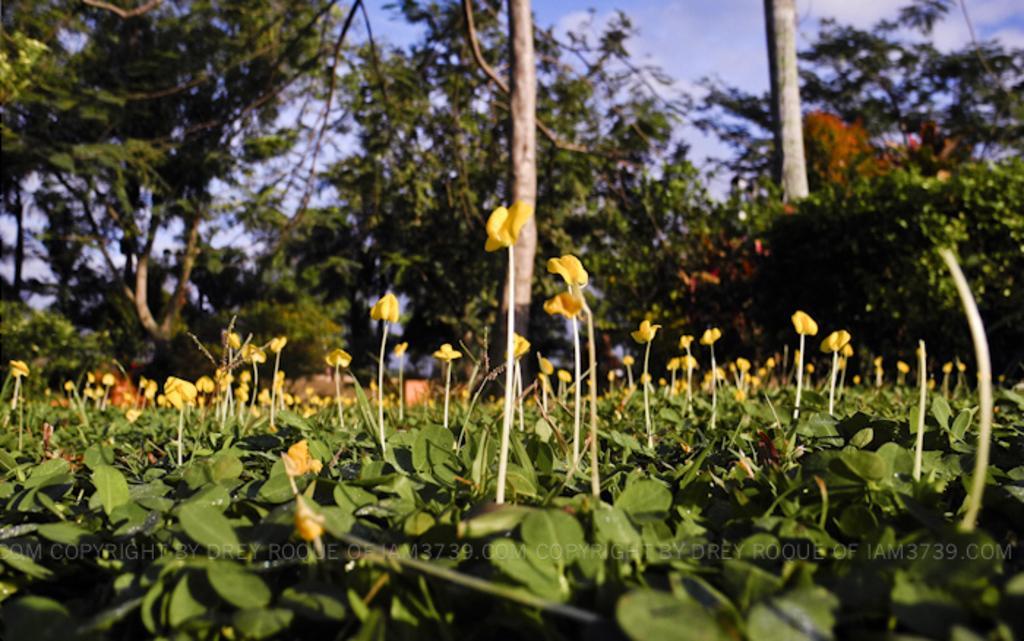Describe this image in one or two sentences. In this image, we can see plants, flowers, some text and there are trees. At the top, there are clouds in the sky. 